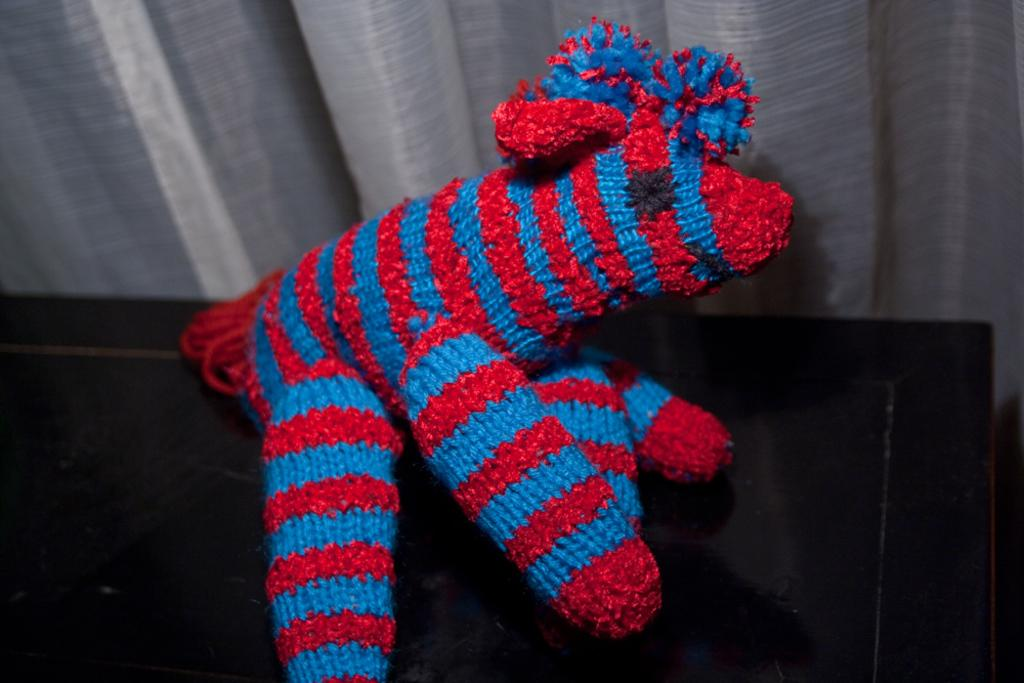What colors are present on the main object in the image? The main object in the image has blue, red, and black colors. What is the object with the blue, red, and black colors resting on? The object is on a black-colored object. What can be seen in the background of the image? There is an ash-colored curtain in the background of the image. Can you tell me how many boats are docked at the harbor in the image? There is no harbor or boats present in the image; it features an object with blue, red, and black colors on a black-colored object, with an ash-colored curtain in the background. 